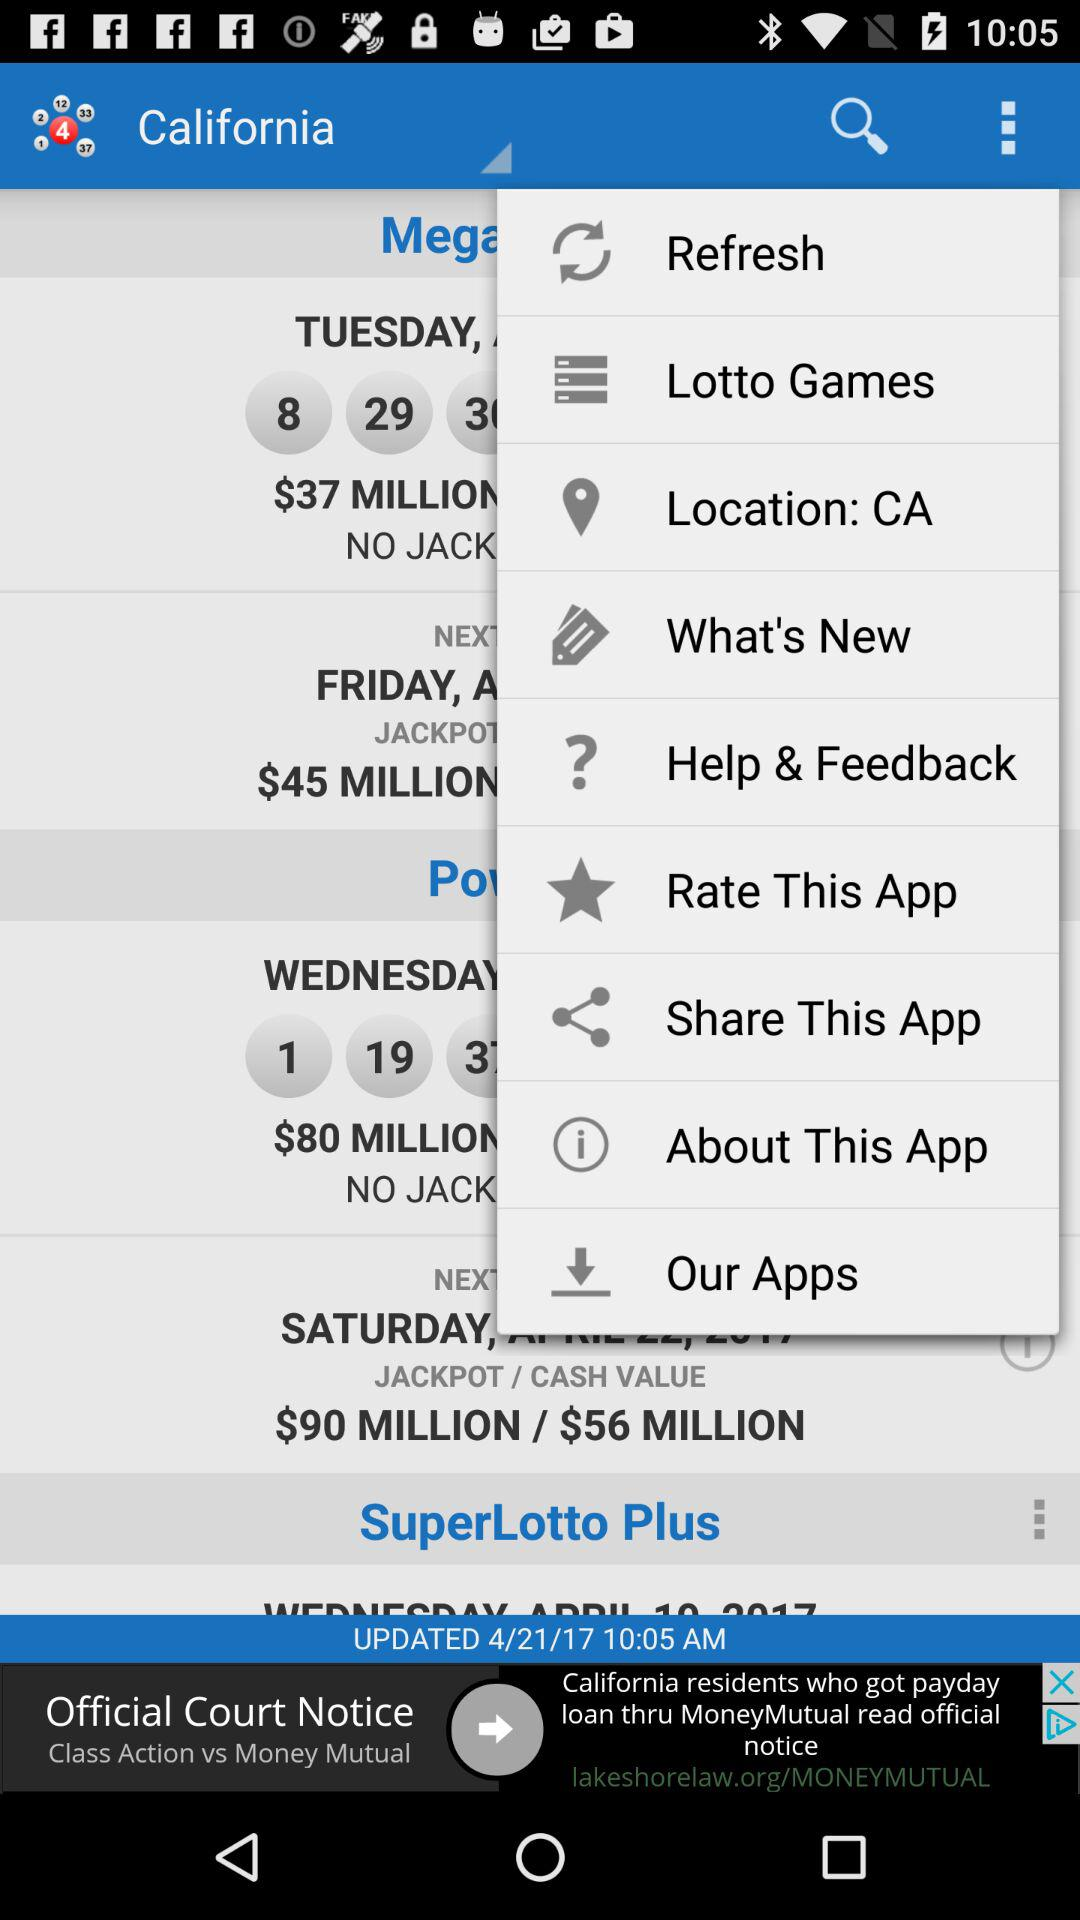What is the current location? The current location is CA. 